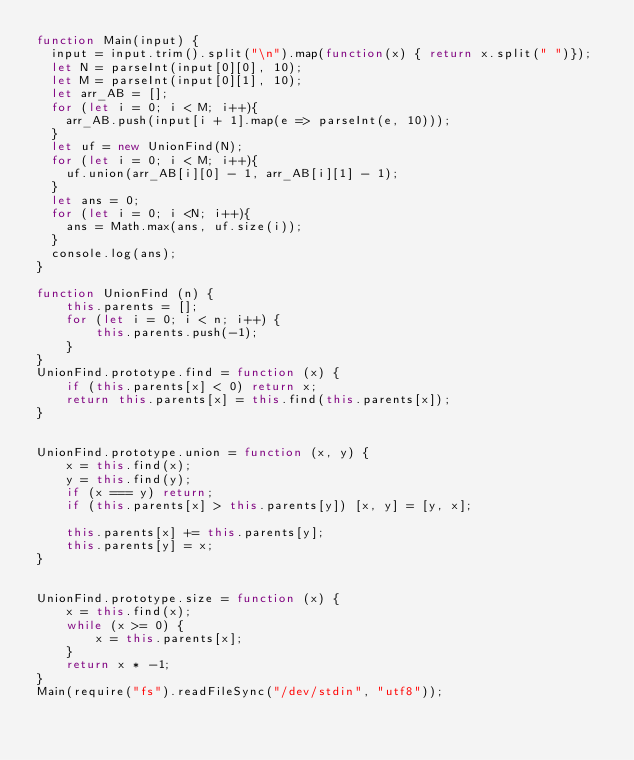Convert code to text. <code><loc_0><loc_0><loc_500><loc_500><_JavaScript_>function Main(input) {
	input = input.trim().split("\n").map(function(x) { return x.split(" ")});
	let N = parseInt(input[0][0], 10);
	let M = parseInt(input[0][1], 10);
	let arr_AB = [];
	for (let i = 0; i < M; i++){
		arr_AB.push(input[i + 1].map(e => parseInt(e, 10)));
	}
	let uf = new UnionFind(N);
	for (let i = 0; i < M; i++){
		uf.union(arr_AB[i][0] - 1, arr_AB[i][1] - 1);
	}
	let ans = 0;
	for (let i = 0; i <N; i++){
		ans = Math.max(ans, uf.size(i));
	}
	console.log(ans);
}

function UnionFind (n) {
    this.parents = [];
    for (let i = 0; i < n; i++) {
        this.parents.push(-1);
    }
}
UnionFind.prototype.find = function (x) {
    if (this.parents[x] < 0) return x;
    return this.parents[x] = this.find(this.parents[x]);    
}


UnionFind.prototype.union = function (x, y) {
    x = this.find(x);
    y = this.find(y);
    if (x === y) return;
    if (this.parents[x] > this.parents[y]) [x, y] = [y, x];
    
    this.parents[x] += this.parents[y];
    this.parents[y] = x;
}


UnionFind.prototype.size = function (x) {
    x = this.find(x);
    while (x >= 0) {
        x = this.parents[x];
    }
    return x * -1;
}
Main(require("fs").readFileSync("/dev/stdin", "utf8"));
</code> 